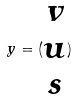<formula> <loc_0><loc_0><loc_500><loc_500>y = ( \begin{matrix} v \\ u \\ s \end{matrix} )</formula> 